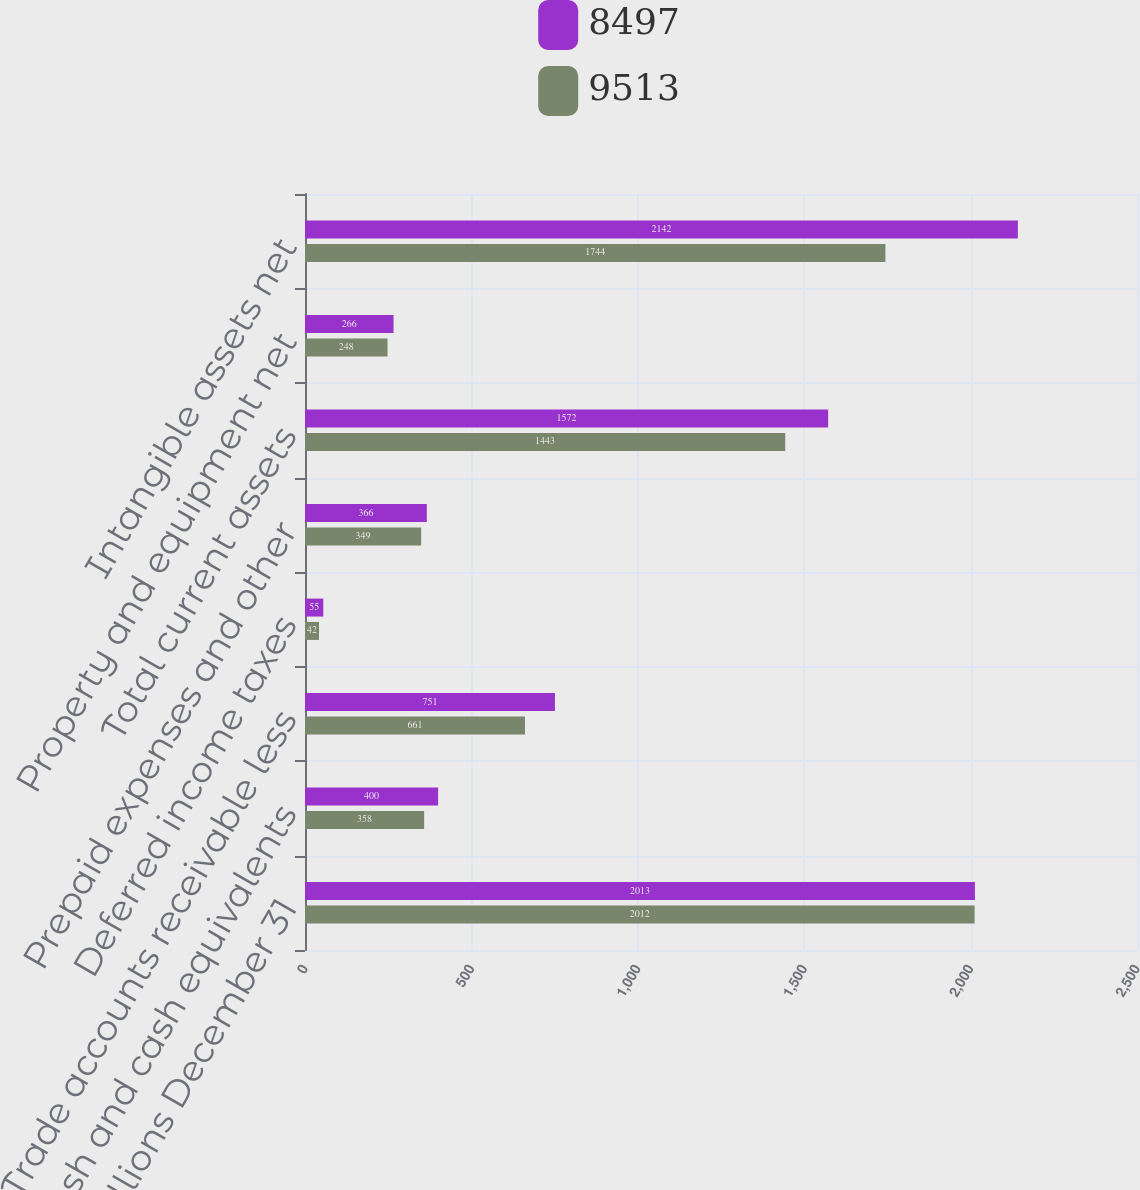Convert chart to OTSL. <chart><loc_0><loc_0><loc_500><loc_500><stacked_bar_chart><ecel><fcel>In millions December 31<fcel>Cash and cash equivalents<fcel>Trade accounts receivable less<fcel>Deferred income taxes<fcel>Prepaid expenses and other<fcel>Total current assets<fcel>Property and equipment net<fcel>Intangible assets net<nl><fcel>8497<fcel>2013<fcel>400<fcel>751<fcel>55<fcel>366<fcel>1572<fcel>266<fcel>2142<nl><fcel>9513<fcel>2012<fcel>358<fcel>661<fcel>42<fcel>349<fcel>1443<fcel>248<fcel>1744<nl></chart> 